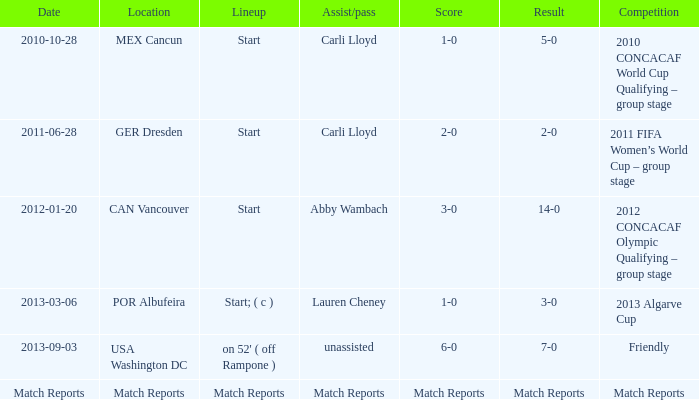Which score has a competition of match reports? Match Reports. 